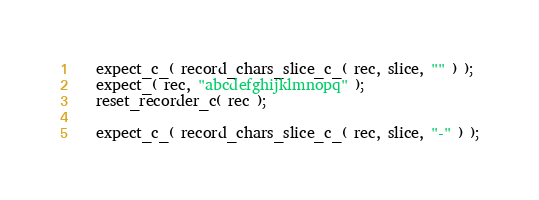<code> <loc_0><loc_0><loc_500><loc_500><_C_>
   expect_c_( record_chars_slice_c_( rec, slice, "" ) );
   expect_( rec, "abcdefghijklmnopq" );
   reset_recorder_c( rec );

   expect_c_( record_chars_slice_c_( rec, slice, "-" ) );</code> 